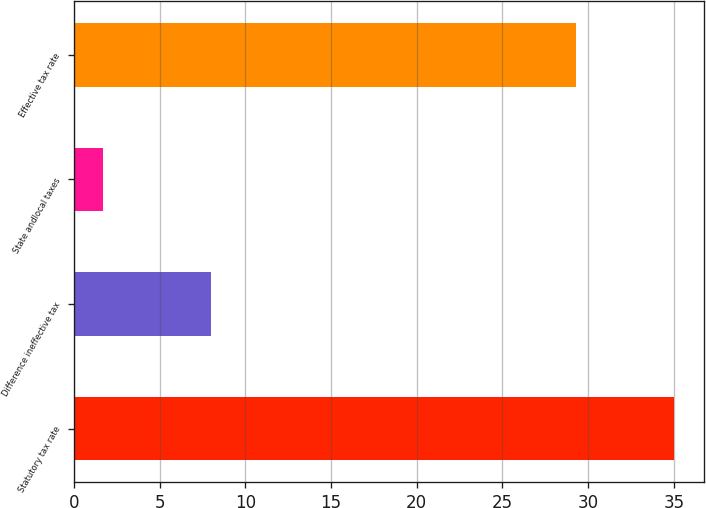Convert chart. <chart><loc_0><loc_0><loc_500><loc_500><bar_chart><fcel>Statutory tax rate<fcel>Difference ineffective tax<fcel>State andlocal taxes<fcel>Effective tax rate<nl><fcel>35<fcel>8<fcel>1.7<fcel>29.3<nl></chart> 